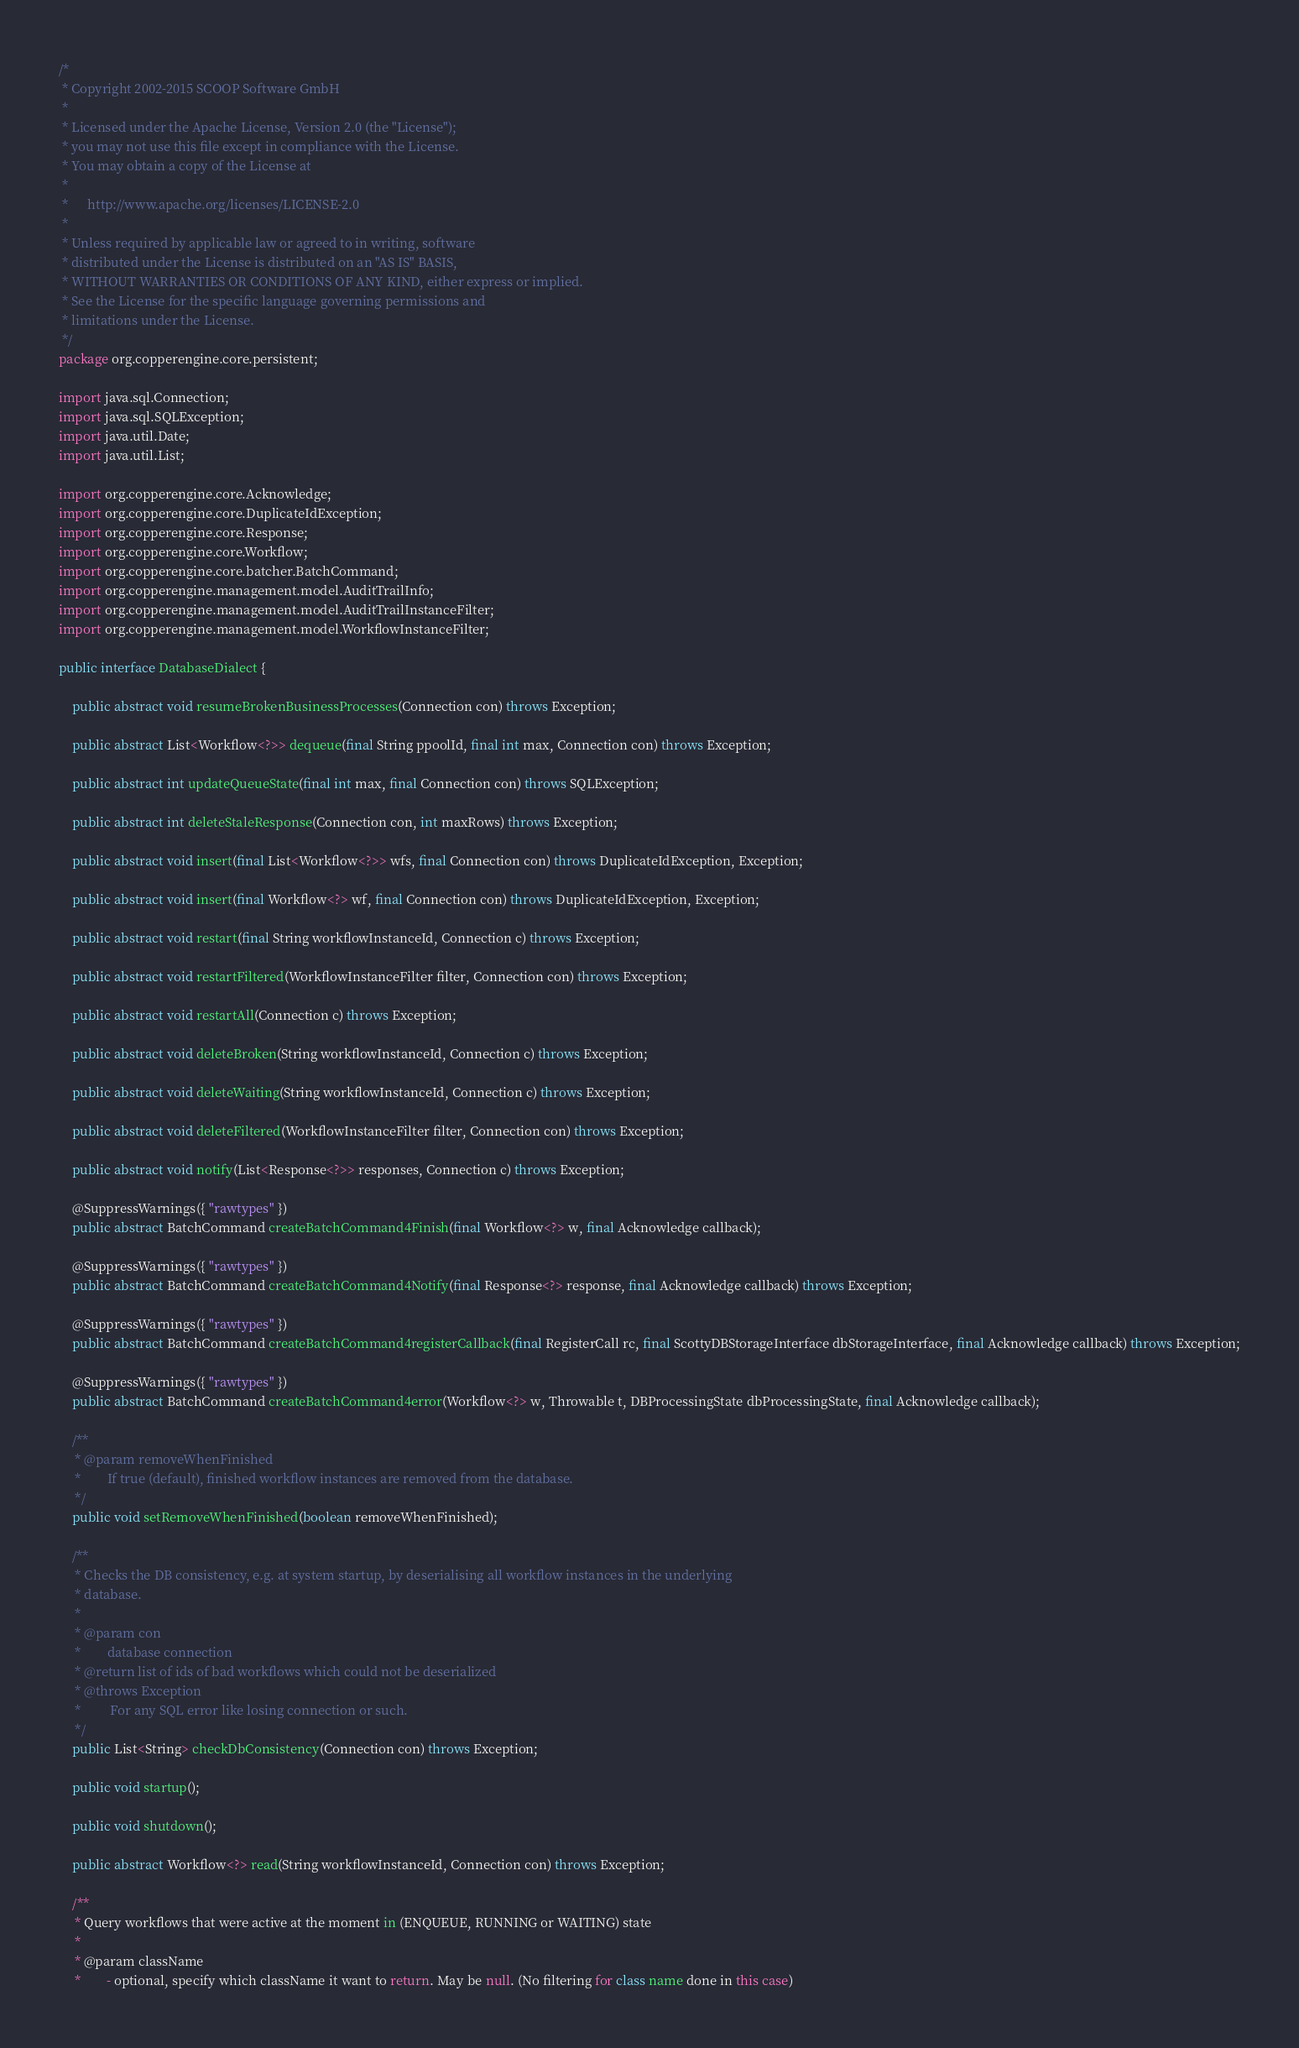<code> <loc_0><loc_0><loc_500><loc_500><_Java_>/*
 * Copyright 2002-2015 SCOOP Software GmbH
 *
 * Licensed under the Apache License, Version 2.0 (the "License");
 * you may not use this file except in compliance with the License.
 * You may obtain a copy of the License at
 *
 *      http://www.apache.org/licenses/LICENSE-2.0
 *
 * Unless required by applicable law or agreed to in writing, software
 * distributed under the License is distributed on an "AS IS" BASIS,
 * WITHOUT WARRANTIES OR CONDITIONS OF ANY KIND, either express or implied.
 * See the License for the specific language governing permissions and
 * limitations under the License.
 */
package org.copperengine.core.persistent;

import java.sql.Connection;
import java.sql.SQLException;
import java.util.Date;
import java.util.List;

import org.copperengine.core.Acknowledge;
import org.copperengine.core.DuplicateIdException;
import org.copperengine.core.Response;
import org.copperengine.core.Workflow;
import org.copperengine.core.batcher.BatchCommand;
import org.copperengine.management.model.AuditTrailInfo;
import org.copperengine.management.model.AuditTrailInstanceFilter;
import org.copperengine.management.model.WorkflowInstanceFilter;

public interface DatabaseDialect {

    public abstract void resumeBrokenBusinessProcesses(Connection con) throws Exception;

    public abstract List<Workflow<?>> dequeue(final String ppoolId, final int max, Connection con) throws Exception;

    public abstract int updateQueueState(final int max, final Connection con) throws SQLException;

    public abstract int deleteStaleResponse(Connection con, int maxRows) throws Exception;

    public abstract void insert(final List<Workflow<?>> wfs, final Connection con) throws DuplicateIdException, Exception;

    public abstract void insert(final Workflow<?> wf, final Connection con) throws DuplicateIdException, Exception;

    public abstract void restart(final String workflowInstanceId, Connection c) throws Exception;

    public abstract void restartFiltered(WorkflowInstanceFilter filter, Connection con) throws Exception;

    public abstract void restartAll(Connection c) throws Exception;

    public abstract void deleteBroken(String workflowInstanceId, Connection c) throws Exception;

    public abstract void deleteWaiting(String workflowInstanceId, Connection c) throws Exception;

    public abstract void deleteFiltered(WorkflowInstanceFilter filter, Connection con) throws Exception;

    public abstract void notify(List<Response<?>> responses, Connection c) throws Exception;

    @SuppressWarnings({ "rawtypes" })
    public abstract BatchCommand createBatchCommand4Finish(final Workflow<?> w, final Acknowledge callback);

    @SuppressWarnings({ "rawtypes" })
    public abstract BatchCommand createBatchCommand4Notify(final Response<?> response, final Acknowledge callback) throws Exception;

    @SuppressWarnings({ "rawtypes" })
    public abstract BatchCommand createBatchCommand4registerCallback(final RegisterCall rc, final ScottyDBStorageInterface dbStorageInterface, final Acknowledge callback) throws Exception;

    @SuppressWarnings({ "rawtypes" })
    public abstract BatchCommand createBatchCommand4error(Workflow<?> w, Throwable t, DBProcessingState dbProcessingState, final Acknowledge callback);

    /**
     * @param removeWhenFinished
     *        If true (default), finished workflow instances are removed from the database.
     */
    public void setRemoveWhenFinished(boolean removeWhenFinished);

    /**
     * Checks the DB consistency, e.g. at system startup, by deserialising all workflow instances in the underlying
     * database.
     * 
     * @param con
     *        database connection
     * @return list of ids of bad workflows which could not be deserialized
     * @throws Exception
     *         For any SQL error like losing connection or such.
     */
    public List<String> checkDbConsistency(Connection con) throws Exception;

    public void startup();

    public void shutdown();

    public abstract Workflow<?> read(String workflowInstanceId, Connection con) throws Exception;

    /**
     * Query workflows that were active at the moment in (ENQUEUE, RUNNING or WAITING) state
     * 
     * @param className
     *        - optional, specify which className it want to return. May be null. (No filtering for class name done in this case)</code> 